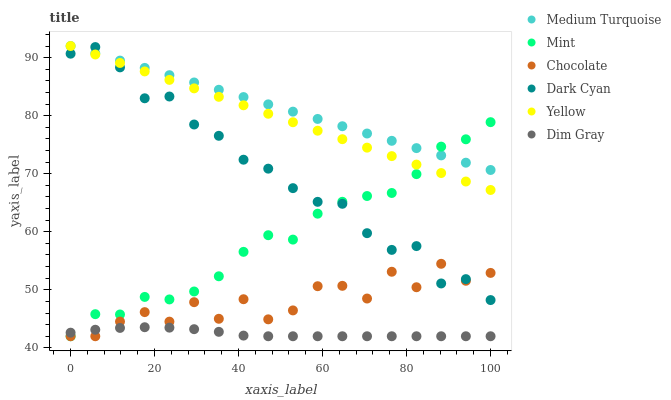Does Dim Gray have the minimum area under the curve?
Answer yes or no. Yes. Does Medium Turquoise have the maximum area under the curve?
Answer yes or no. Yes. Does Yellow have the minimum area under the curve?
Answer yes or no. No. Does Yellow have the maximum area under the curve?
Answer yes or no. No. Is Medium Turquoise the smoothest?
Answer yes or no. Yes. Is Chocolate the roughest?
Answer yes or no. Yes. Is Yellow the smoothest?
Answer yes or no. No. Is Yellow the roughest?
Answer yes or no. No. Does Dim Gray have the lowest value?
Answer yes or no. Yes. Does Yellow have the lowest value?
Answer yes or no. No. Does Medium Turquoise have the highest value?
Answer yes or no. Yes. Does Chocolate have the highest value?
Answer yes or no. No. Is Dim Gray less than Dark Cyan?
Answer yes or no. Yes. Is Yellow greater than Dim Gray?
Answer yes or no. Yes. Does Medium Turquoise intersect Mint?
Answer yes or no. Yes. Is Medium Turquoise less than Mint?
Answer yes or no. No. Is Medium Turquoise greater than Mint?
Answer yes or no. No. Does Dim Gray intersect Dark Cyan?
Answer yes or no. No. 